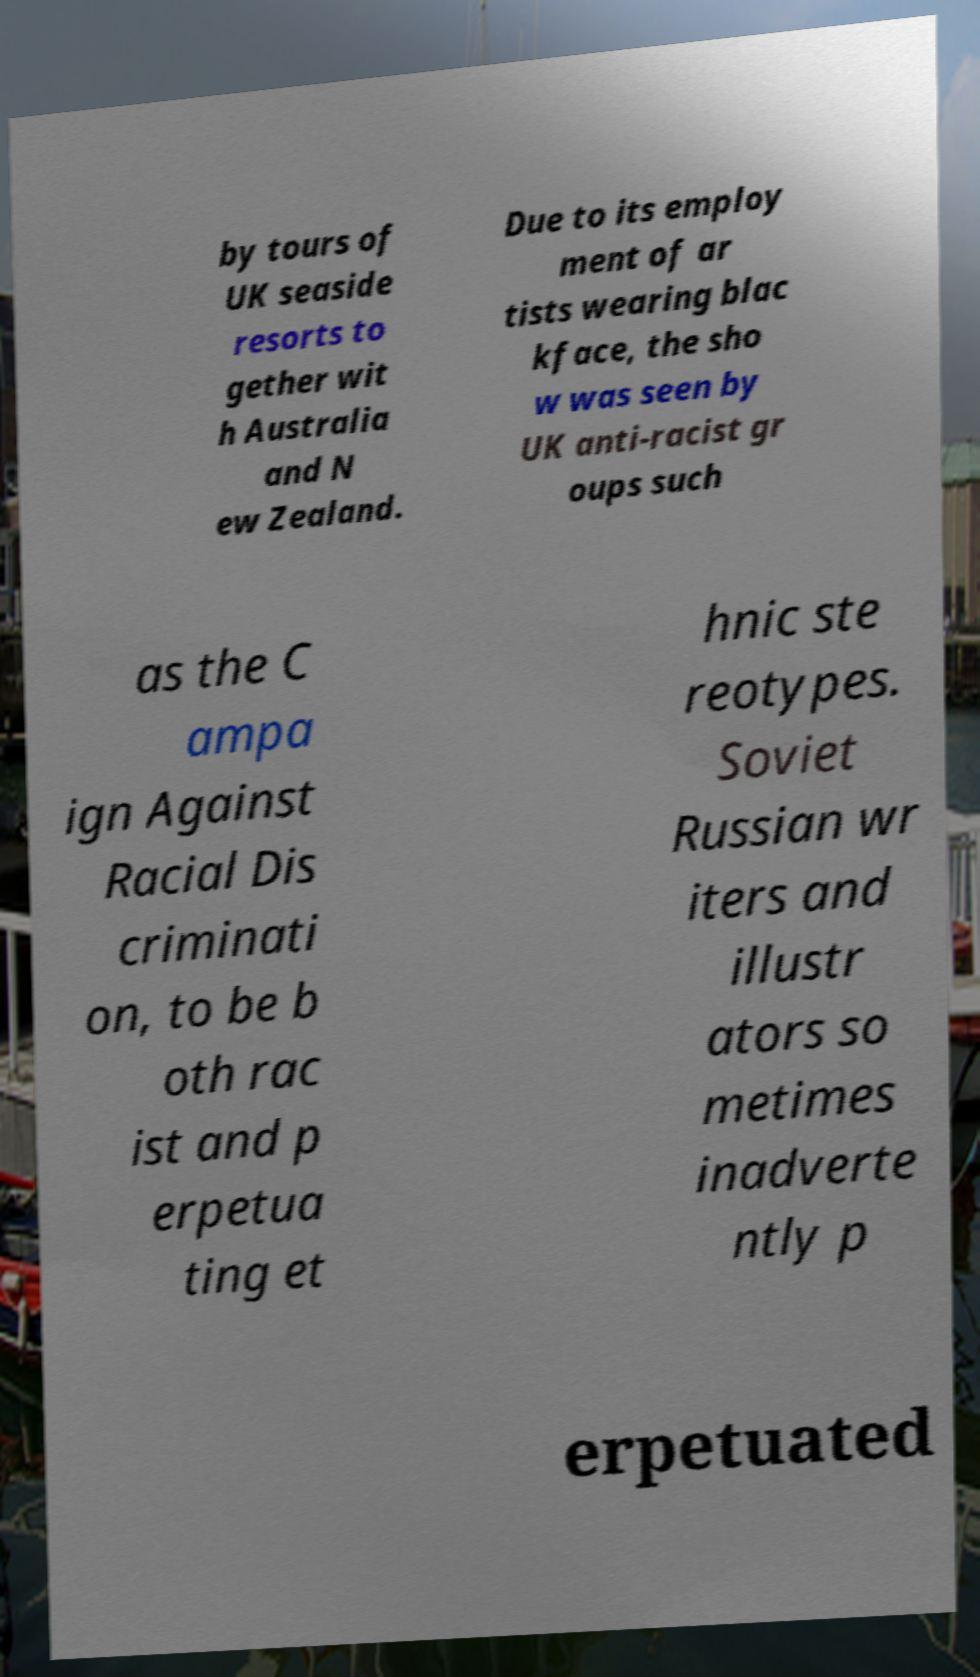Can you accurately transcribe the text from the provided image for me? by tours of UK seaside resorts to gether wit h Australia and N ew Zealand. Due to its employ ment of ar tists wearing blac kface, the sho w was seen by UK anti-racist gr oups such as the C ampa ign Against Racial Dis criminati on, to be b oth rac ist and p erpetua ting et hnic ste reotypes. Soviet Russian wr iters and illustr ators so metimes inadverte ntly p erpetuated 